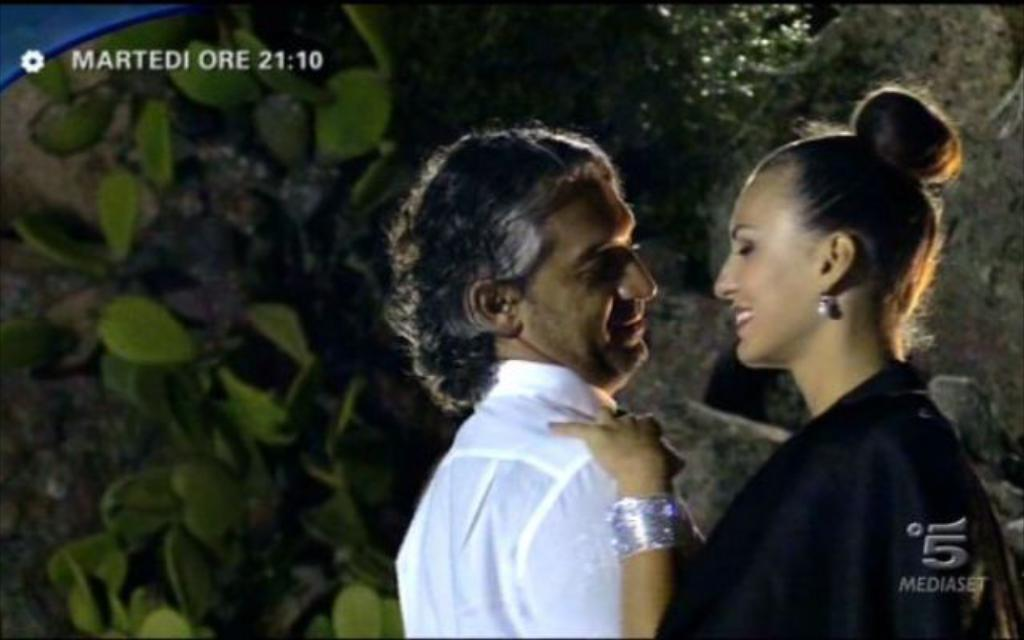How many people are present in the image? There are two people in the image, a woman and a man. What can be seen in the background of the image? There is a tree in the image. What type of language is the woman speaking in the image? There is no indication of the language being spoken in the image, as it is a visual medium. 